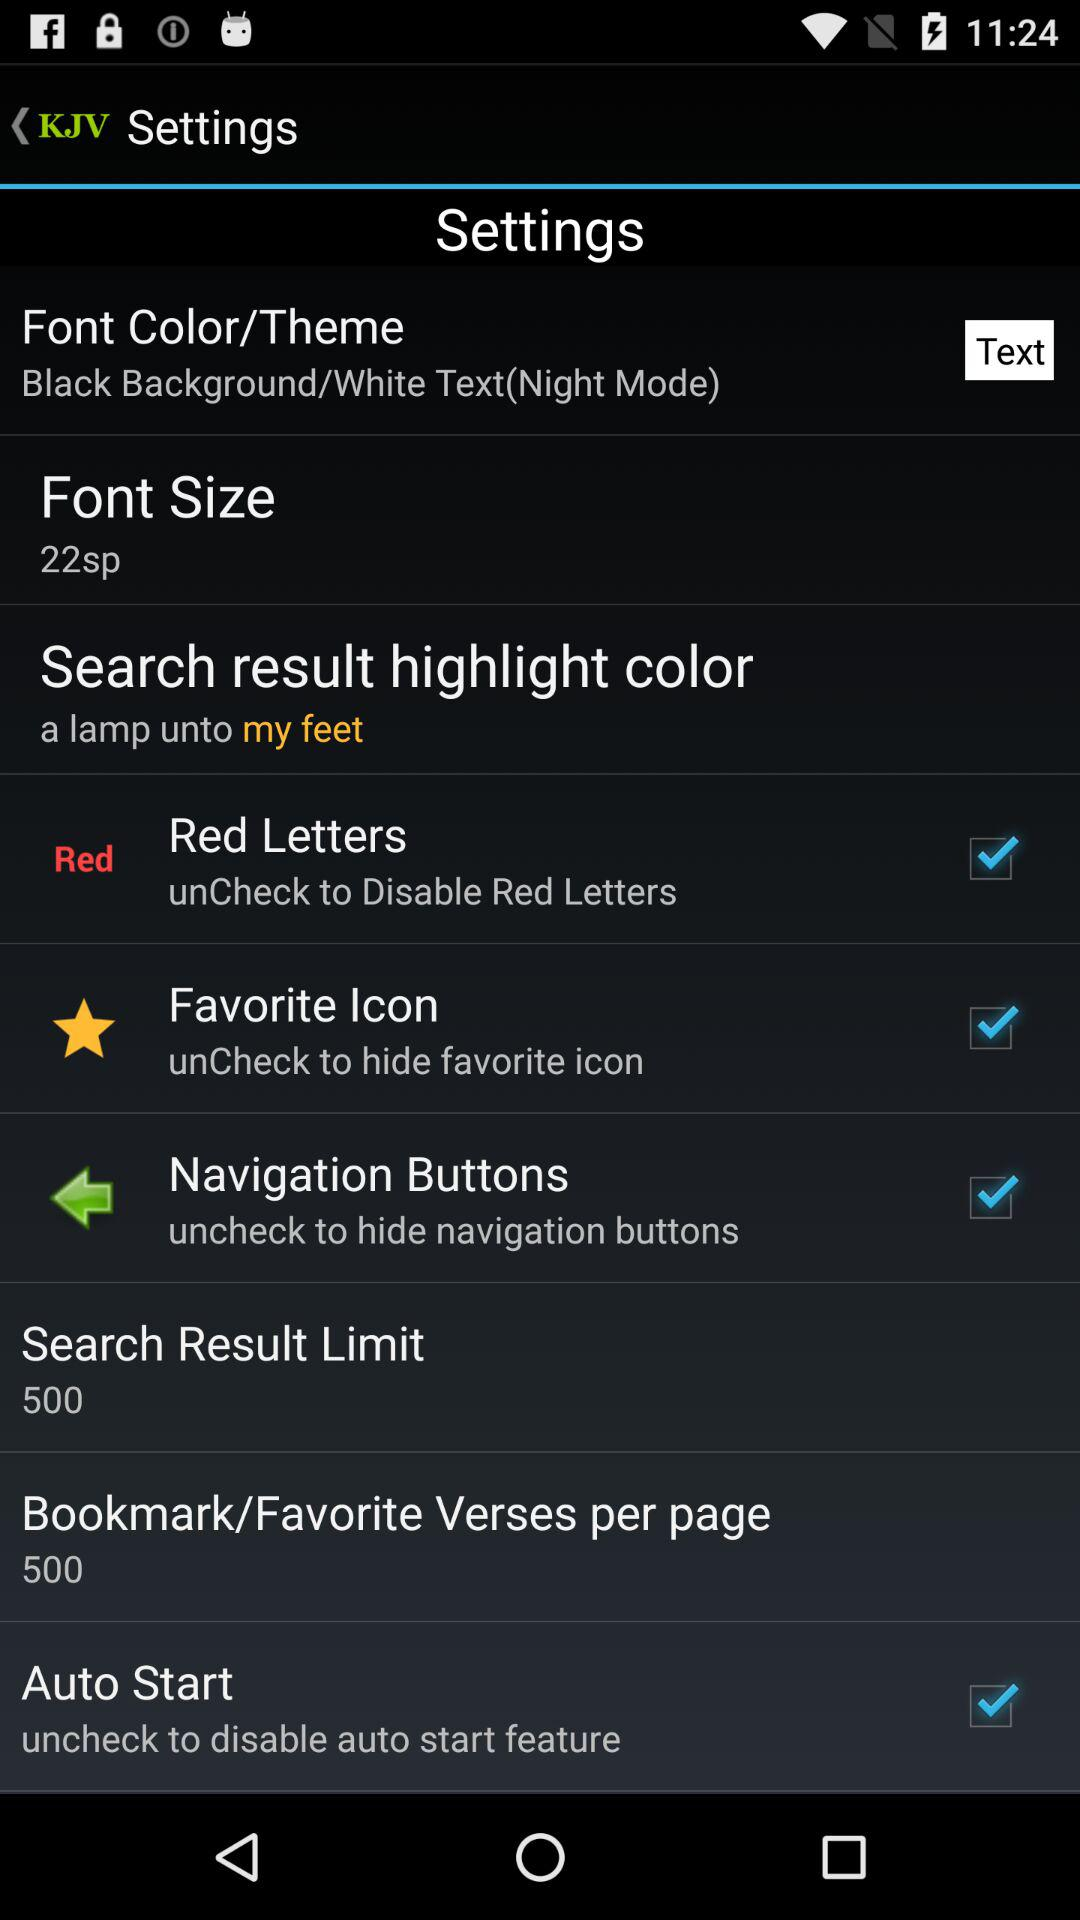What is the value set for "Bookmark/Favorite Verses per page"? The value set for "Bookmark/Favorite Verses per page" is 500. 